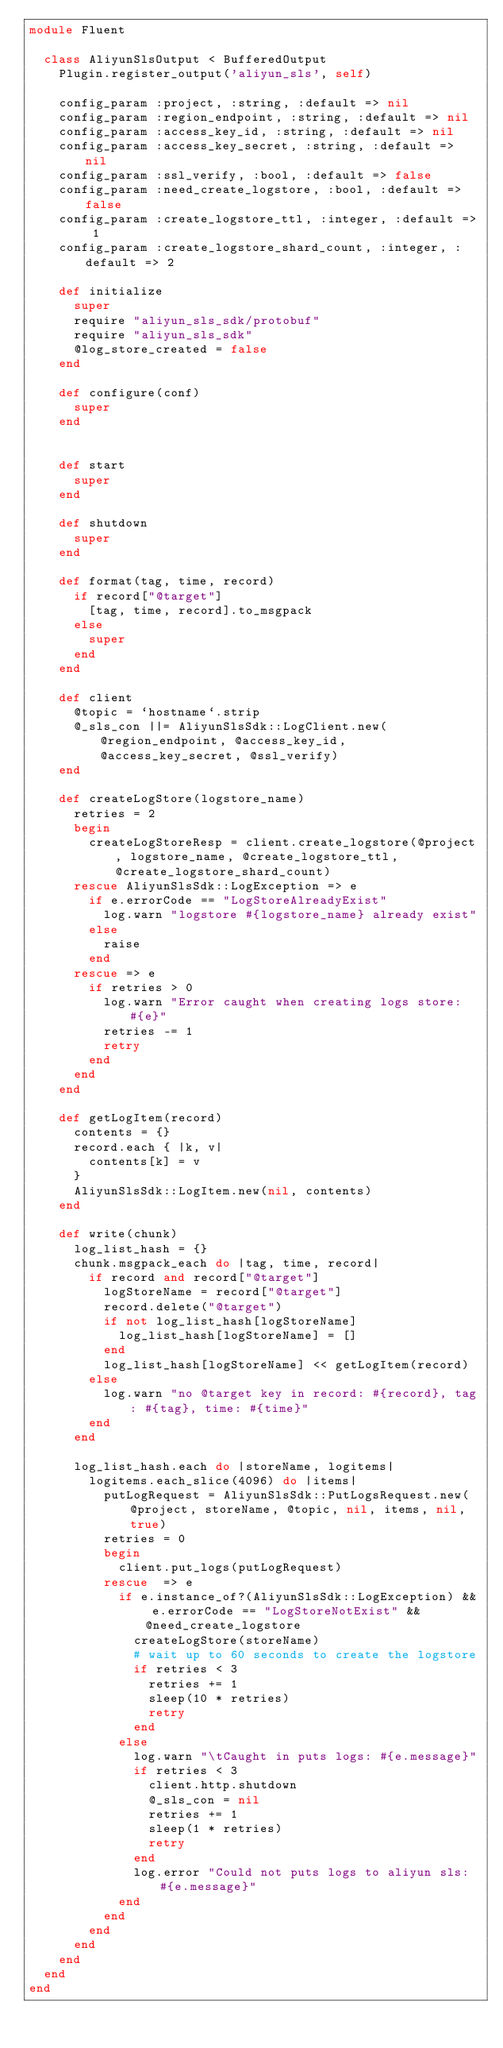Convert code to text. <code><loc_0><loc_0><loc_500><loc_500><_Ruby_>module Fluent

  class AliyunSlsOutput < BufferedOutput
    Plugin.register_output('aliyun_sls', self)

    config_param :project, :string, :default => nil
    config_param :region_endpoint, :string, :default => nil
    config_param :access_key_id, :string, :default => nil
    config_param :access_key_secret, :string, :default => nil
    config_param :ssl_verify, :bool, :default => false
    config_param :need_create_logstore, :bool, :default => false
    config_param :create_logstore_ttl, :integer, :default => 1
    config_param :create_logstore_shard_count, :integer, :default => 2

    def initialize
      super
      require "aliyun_sls_sdk/protobuf"
      require "aliyun_sls_sdk"
      @log_store_created = false
    end

    def configure(conf)
      super
    end


    def start
      super
    end

    def shutdown
      super
    end

    def format(tag, time, record)
      if record["@target"]
        [tag, time, record].to_msgpack
      else
        super
      end
    end

    def client
      @topic = `hostname`.strip
      @_sls_con ||= AliyunSlsSdk::LogClient.new(@region_endpoint, @access_key_id, @access_key_secret, @ssl_verify)
    end

    def createLogStore(logstore_name)
      retries = 2
      begin
        createLogStoreResp = client.create_logstore(@project, logstore_name, @create_logstore_ttl, @create_logstore_shard_count)
      rescue AliyunSlsSdk::LogException => e
        if e.errorCode == "LogStoreAlreadyExist"
          log.warn "logstore #{logstore_name} already exist"
        else
          raise
        end
      rescue => e
        if retries > 0
          log.warn "Error caught when creating logs store: #{e}"
          retries -= 1
          retry
        end
      end
    end

    def getLogItem(record)
      contents = {}
      record.each { |k, v|
        contents[k] = v
      }
      AliyunSlsSdk::LogItem.new(nil, contents)
    end

    def write(chunk)
      log_list_hash = {}
      chunk.msgpack_each do |tag, time, record|
        if record and record["@target"]
          logStoreName = record["@target"]
          record.delete("@target")
          if not log_list_hash[logStoreName]
            log_list_hash[logStoreName] = []
          end
          log_list_hash[logStoreName] << getLogItem(record)
        else
          log.warn "no @target key in record: #{record}, tag: #{tag}, time: #{time}"
        end
      end

      log_list_hash.each do |storeName, logitems|
        logitems.each_slice(4096) do |items|
          putLogRequest = AliyunSlsSdk::PutLogsRequest.new(@project, storeName, @topic, nil, items, nil, true)
          retries = 0
          begin
            client.put_logs(putLogRequest)
          rescue  => e
            if e.instance_of?(AliyunSlsSdk::LogException) && e.errorCode == "LogStoreNotExist" && @need_create_logstore
              createLogStore(storeName)
              # wait up to 60 seconds to create the logstore
              if retries < 3
                retries += 1
                sleep(10 * retries)
                retry
              end
            else
              log.warn "\tCaught in puts logs: #{e.message}"
              if retries < 3
                client.http.shutdown
                @_sls_con = nil
                retries += 1
                sleep(1 * retries)
                retry
              end
              log.error "Could not puts logs to aliyun sls: #{e.message}"
            end
          end
        end
      end
    end
  end
end
</code> 